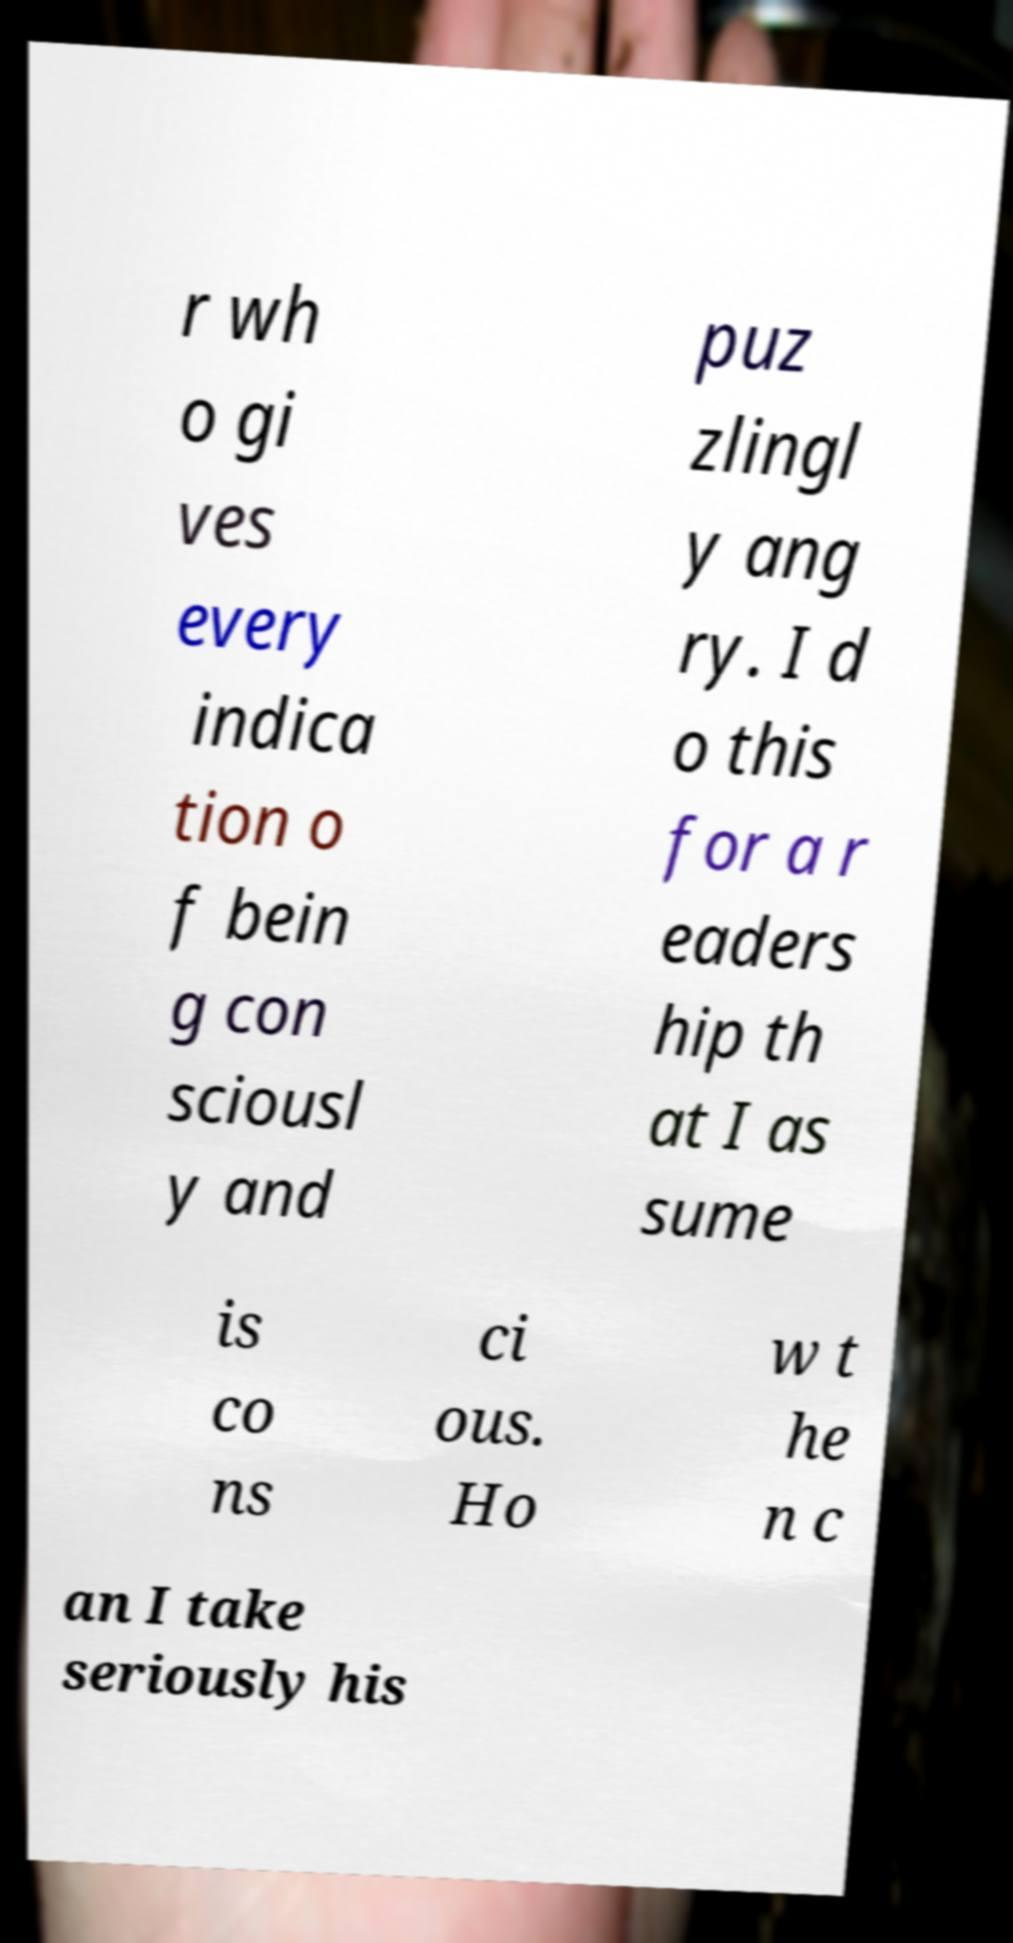What messages or text are displayed in this image? I need them in a readable, typed format. r wh o gi ves every indica tion o f bein g con sciousl y and puz zlingl y ang ry. I d o this for a r eaders hip th at I as sume is co ns ci ous. Ho w t he n c an I take seriously his 